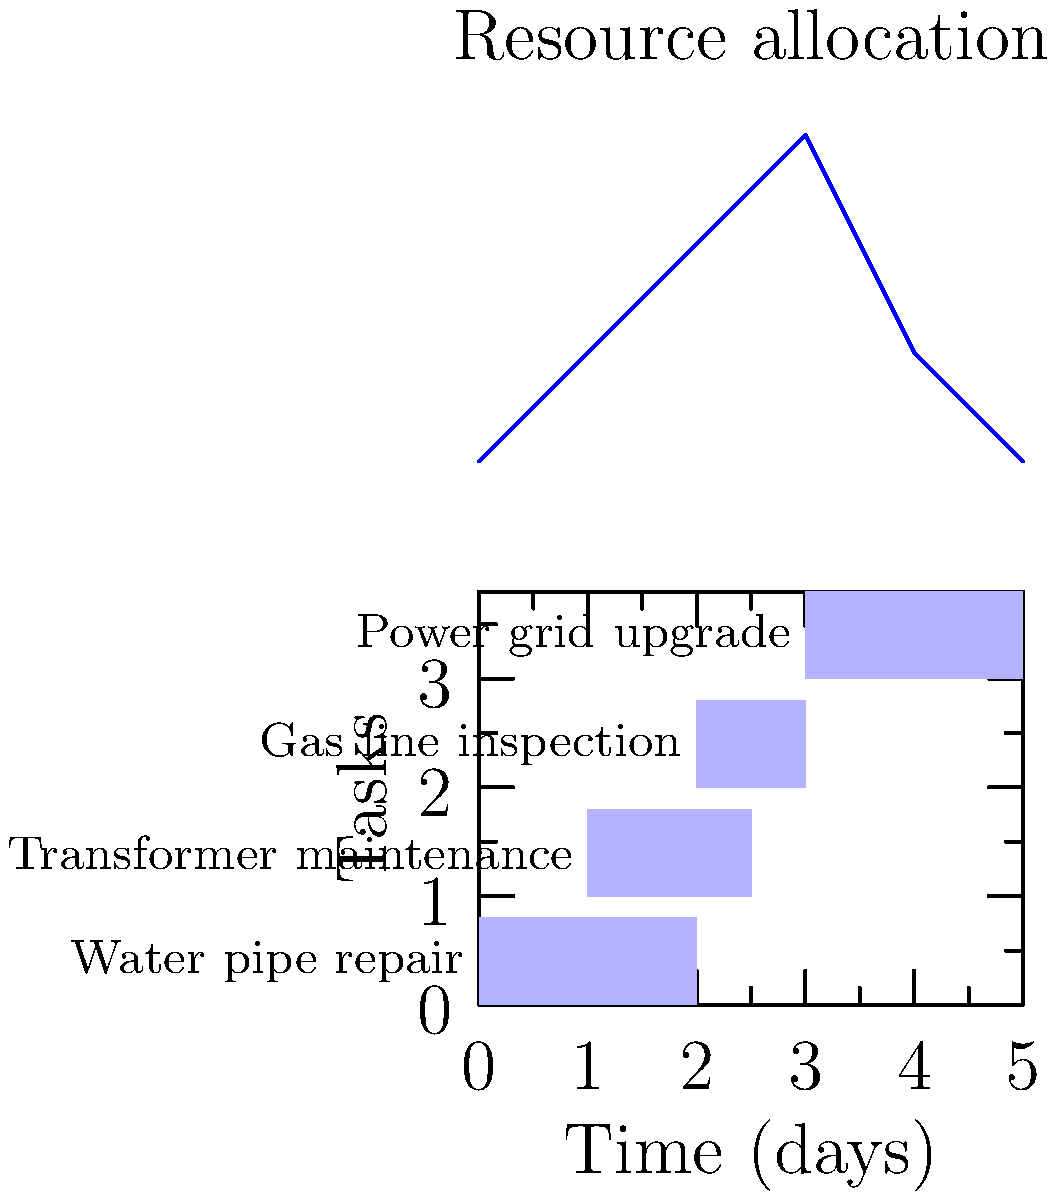Based on the Gantt chart and resource allocation graph provided, which day has the highest resource demand, and what is the maximum number of resources required on that day? To answer this question, we need to analyze both the Gantt chart and the resource allocation graph:

1. First, let's examine the Gantt chart:
   - Water pipe repair: Days 0-2
   - Transformer maintenance: Days 1-2.5
   - Gas line inspection: Days 2-3
   - Power grid upgrade: Days 3-5

2. Now, let's look at the resource allocation graph:
   - The graph shows the number of resources required each day
   - The y-axis represents the number of resources
   - The x-axis represents the days

3. Analyzing the resource allocation graph:
   - Day 0: 5 resources
   - Day 1: 6 resources
   - Day 2: 7 resources
   - Day 3: 8 resources (peak)
   - Day 4: 6 resources
   - Day 5: 5 resources

4. Identifying the day with the highest resource demand:
   - The graph peaks on Day 3, indicating the highest resource demand

5. Determining the maximum number of resources required:
   - The peak of the graph corresponds to 8 resources

Therefore, Day 3 has the highest resource demand, with a maximum of 8 resources required.
Answer: Day 3, 8 resources 